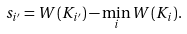Convert formula to latex. <formula><loc_0><loc_0><loc_500><loc_500>s _ { i ^ { \prime } } = W ( K _ { i ^ { \prime } } ) - \min _ { i } W ( K _ { i } ) .</formula> 